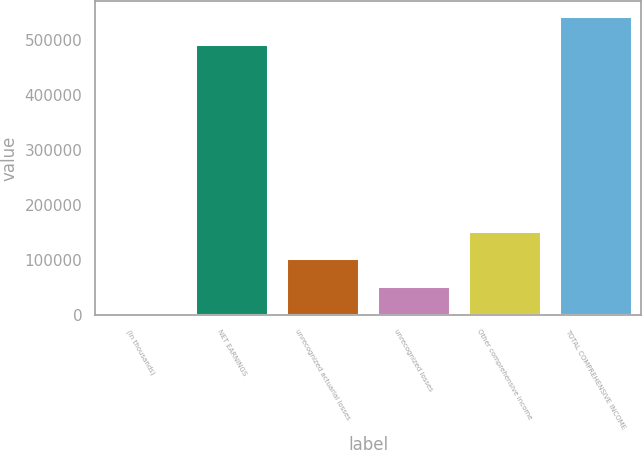Convert chart to OTSL. <chart><loc_0><loc_0><loc_500><loc_500><bar_chart><fcel>(In thousands)<fcel>NET EARNINGS<fcel>unrecognized actuarial losses<fcel>unrecognized losses<fcel>Other comprehensive income<fcel>TOTAL COMPREHENSIVE INCOME<nl><fcel>2014<fcel>492586<fcel>102836<fcel>52424.9<fcel>153247<fcel>542997<nl></chart> 